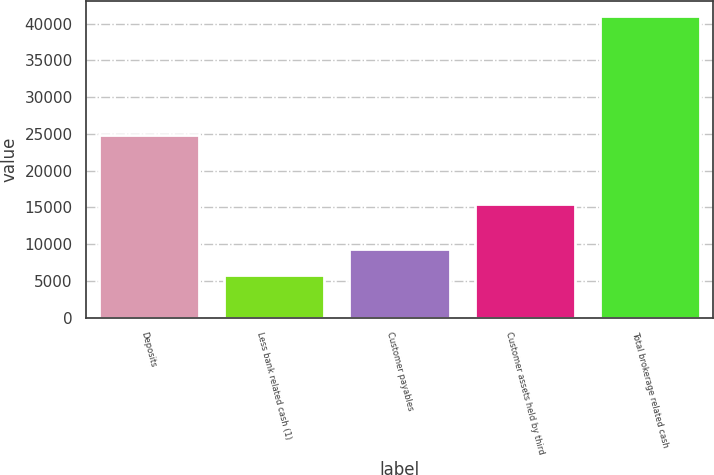Convert chart to OTSL. <chart><loc_0><loc_0><loc_500><loc_500><bar_chart><fcel>Deposits<fcel>Less bank related cash (1)<fcel>Customer payables<fcel>Customer assets held by third<fcel>Total brokerage related cash<nl><fcel>24890<fcel>5771<fcel>9303.3<fcel>15520<fcel>41094<nl></chart> 